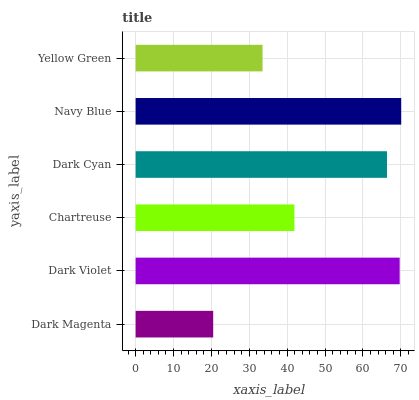Is Dark Magenta the minimum?
Answer yes or no. Yes. Is Navy Blue the maximum?
Answer yes or no. Yes. Is Dark Violet the minimum?
Answer yes or no. No. Is Dark Violet the maximum?
Answer yes or no. No. Is Dark Violet greater than Dark Magenta?
Answer yes or no. Yes. Is Dark Magenta less than Dark Violet?
Answer yes or no. Yes. Is Dark Magenta greater than Dark Violet?
Answer yes or no. No. Is Dark Violet less than Dark Magenta?
Answer yes or no. No. Is Dark Cyan the high median?
Answer yes or no. Yes. Is Chartreuse the low median?
Answer yes or no. Yes. Is Yellow Green the high median?
Answer yes or no. No. Is Dark Violet the low median?
Answer yes or no. No. 